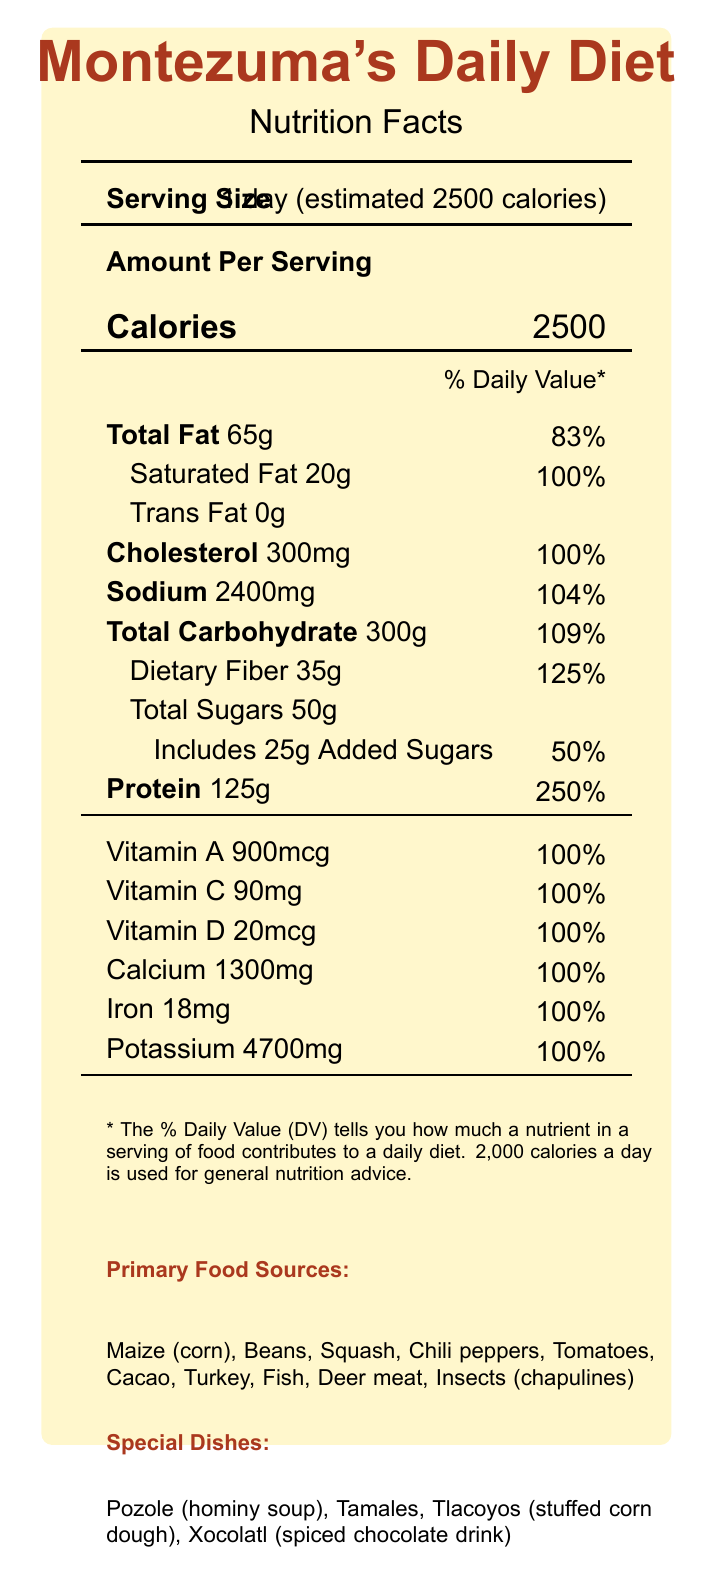what is the serving size? The serving size is stated at the top of the Nutrition Facts section in the document.
Answer: 1 day (estimated 2500 calories) How many grams of total fat are there in Montezuma's diet per day? The total fat amount is listed under Total Fat in the macronutrient section.
Answer: 65g What percentage of the daily value is the sodium intake in Montezuma’s daily diet? The sodium intake is 2400mg, listed with a daily value percentage of 104%.
Answer: 104% How many grams of dietary fiber does Montezuma's daily diet provide? Dietary fiber is listed under Total Carbohydrate with an amount of 35g.
Answer: 35g What is the amount of Vitamin A in Montezuma's daily diet? The amount of Vitamin A is listed clearly in the micronutrient section as 900mcg, with a daily value of 100%.
Answer: 900mcg How much calcium is present in Montezuma's diet per day? Calcium is listed in the micronutrient section with an amount of 1300mg and a daily value of 100%.
Answer: 1300mg Which of the following is not a primary food source mentioned in Montezuma's diet? A. Turkey B. Maize C. Chicken D. Fish Primary food sources include Maize (corn), Beans, Squash, Chili peppers, Tomatoes, Cacao, Turkey, Fish, Deer meat, and Insects (chapulines), but not Chicken.
Answer: C. Chicken Which special dish is included in Montezuma's daily diet? A. Pozole B. Tacos C. Quesadillas D. Burritos The document lists special dishes such as Pozole, Tamales, Tlacoyos, and Xocolatl, but not Tacos, Quesadillas, or Burritos.
Answer: A. Pozole Is there any trans fat in Montezuma's daily diet? The document states "Trans Fat 0g," indicating there is no trans fat in Montezuma's daily diet.
Answer: No Summarize the main idea of the document. The document is formatted as a nutrition facts label, breaking down Montezuma's daily intake of calories, fats, carbohydrates, proteins, vitamins, and minerals. It also outlines key aspects of Aztec dietary practices and their benefits.
Answer: The document provides detailed nutritional information about Montezuma's estimated daily diet, including macronutrient and micronutrient breakdowns, primary food sources, special dishes, and dietary restrictions. It also highlights the nutritional efficiency and agricultural innovations of the Aztec diet. What is the total calorie intake per day as stated in the document? The document mentions that the serving size for Montezuma's daily diet is estimated at 2500 calories.
Answer: 2500 Does the document provide information on the exact recipe for any special dish? The document lists special dishes but does not provide detailed recipes or preparation instructions for them.
Answer: Cannot be determined 